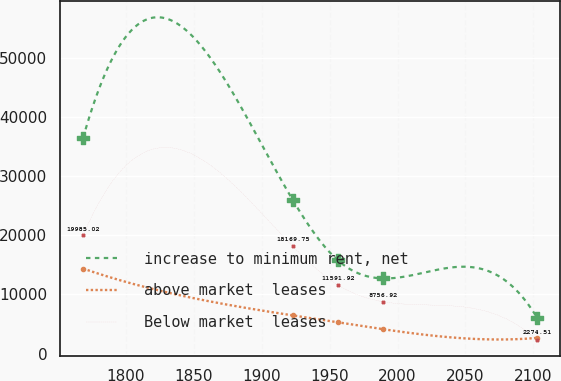Convert chart to OTSL. <chart><loc_0><loc_0><loc_500><loc_500><line_chart><ecel><fcel>increase to minimum rent, net<fcel>above market  leases<fcel>Below market  leases<nl><fcel>1768.76<fcel>36498.9<fcel>14375.3<fcel>19985<nl><fcel>1922.87<fcel>26014.8<fcel>6452.96<fcel>18169.8<nl><fcel>1956.26<fcel>15753.7<fcel>5280.48<fcel>11591.9<nl><fcel>1989.65<fcel>12709<fcel>4108<fcel>8756.92<nl><fcel>2102.67<fcel>6052.3<fcel>2650.54<fcel>2274.51<nl></chart> 